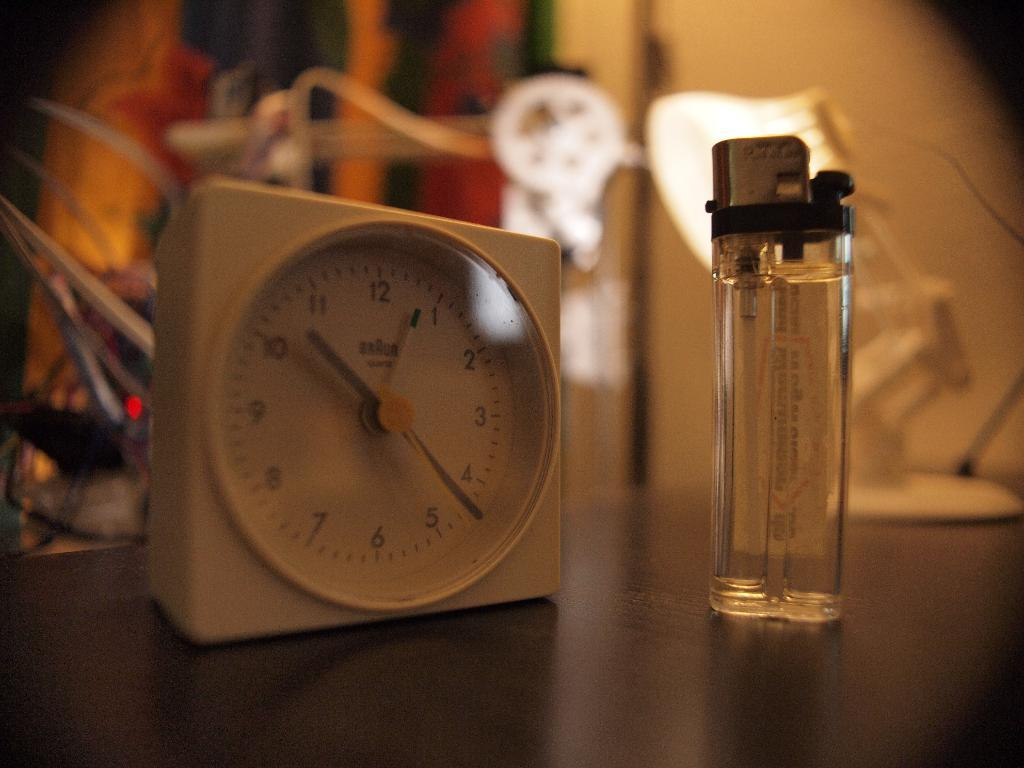<image>
Share a concise interpretation of the image provided. A Braun clock sitting next to a lighter 